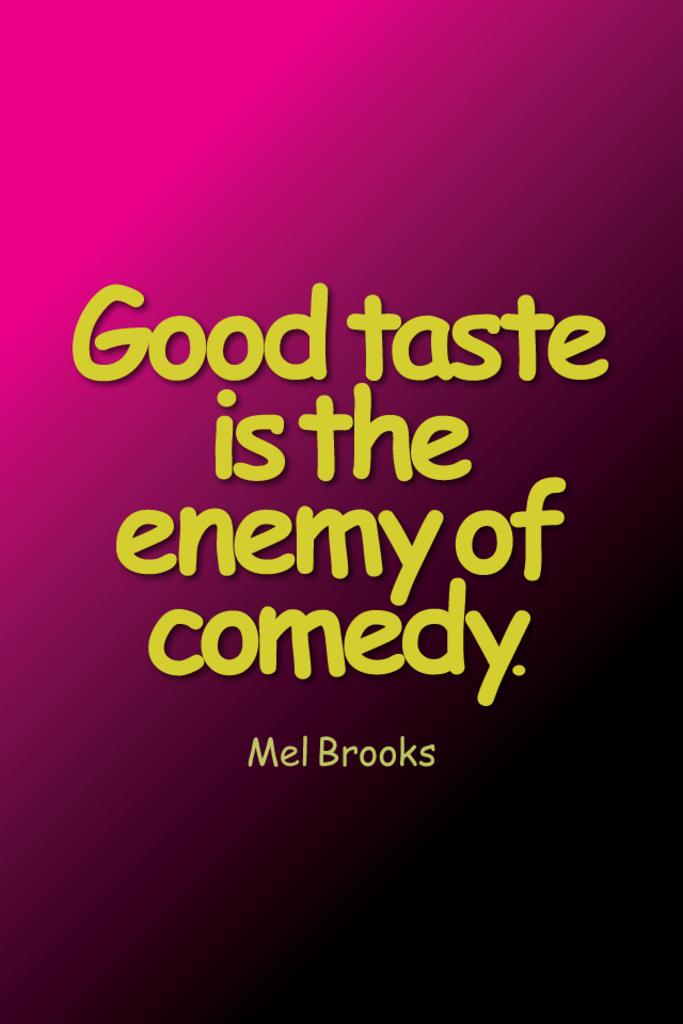Who's quote is this?
Ensure brevity in your answer.  Mel brooks. This a qoutes?
Provide a short and direct response. Yes. 